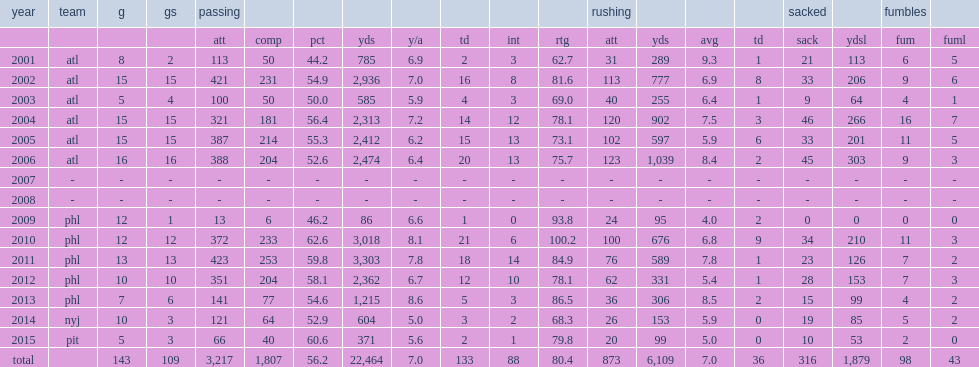How many rushing yards did michael vick have in the 2006 season? 6109.0. How many rushing yards did michael vick make in the 2006 season? 1039.0. 